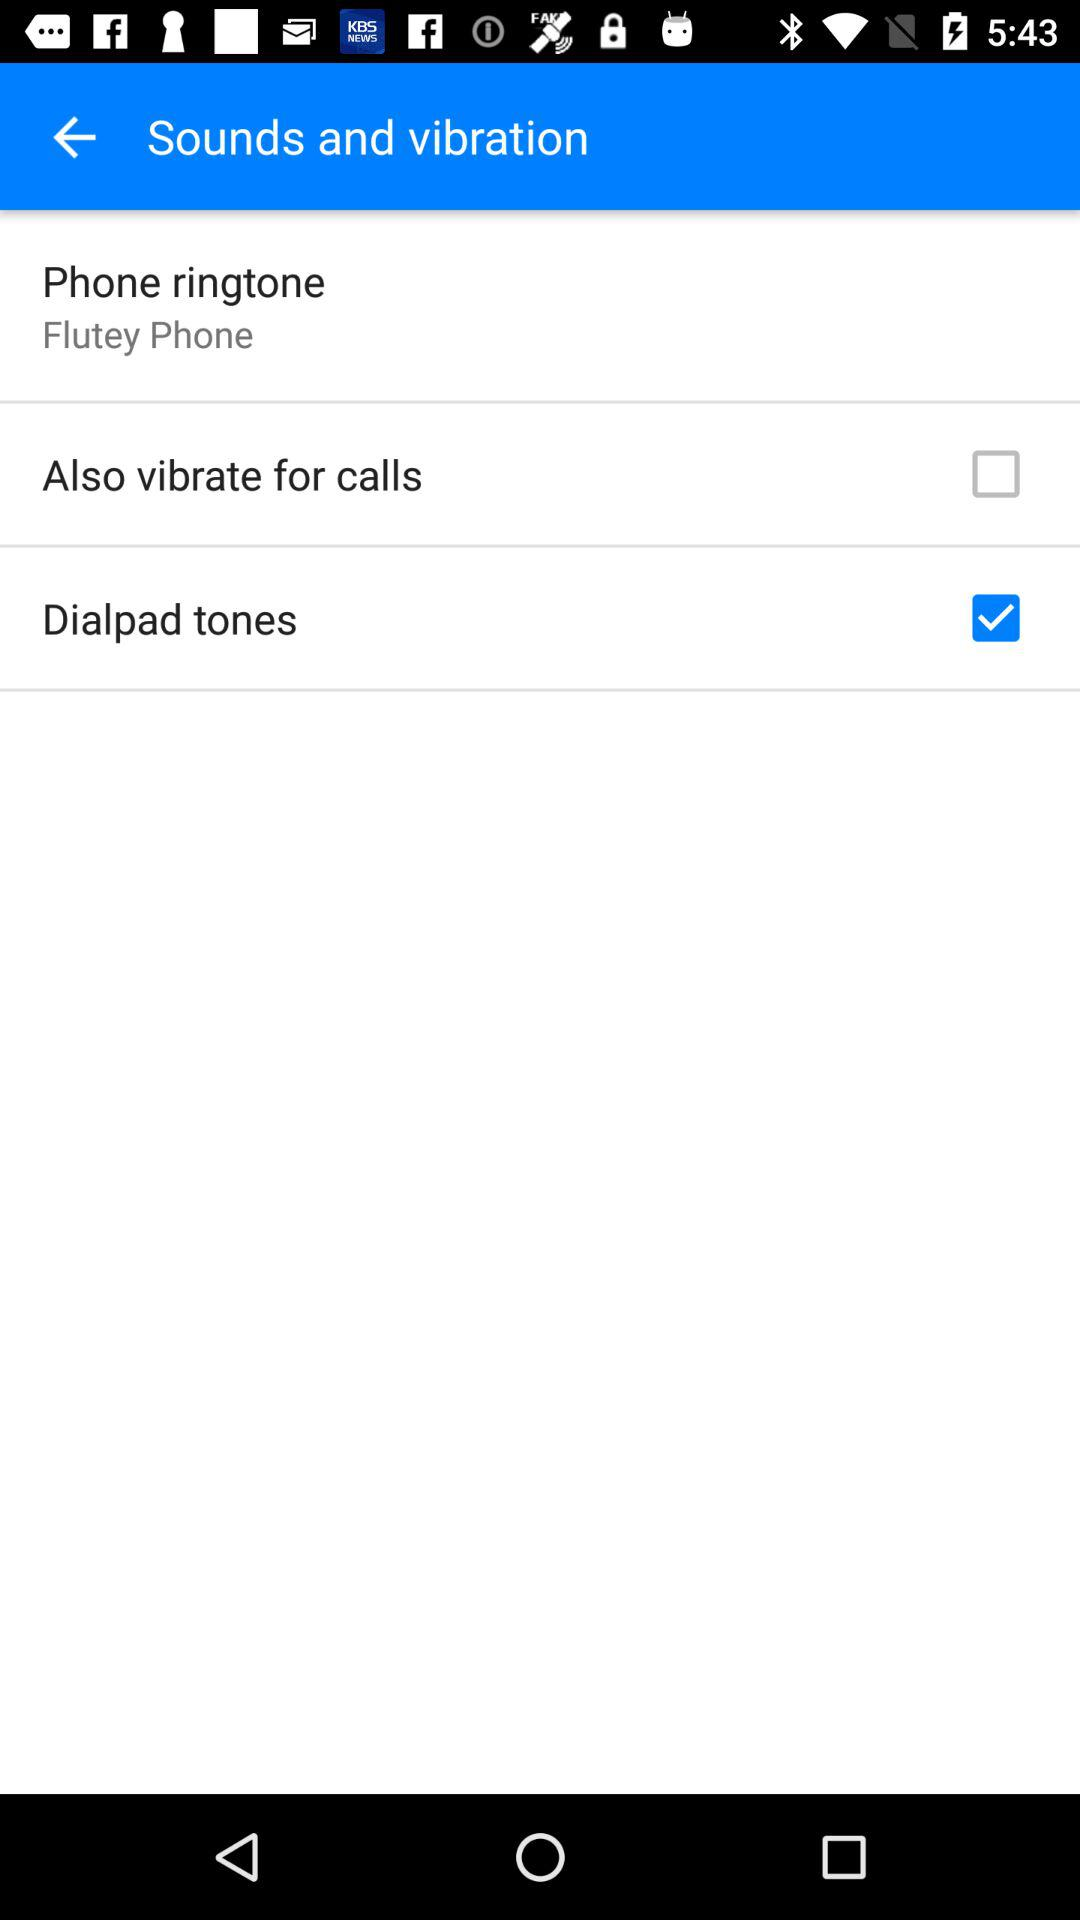What is the status of "Also vibrate for calls" in "Sounds and vibration"? The status is "off". 